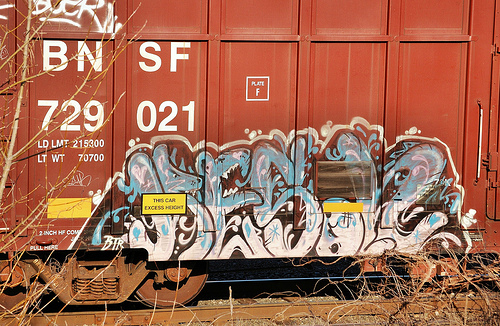<image>
Is the graffiti in front of the box car? No. The graffiti is not in front of the box car. The spatial positioning shows a different relationship between these objects. 